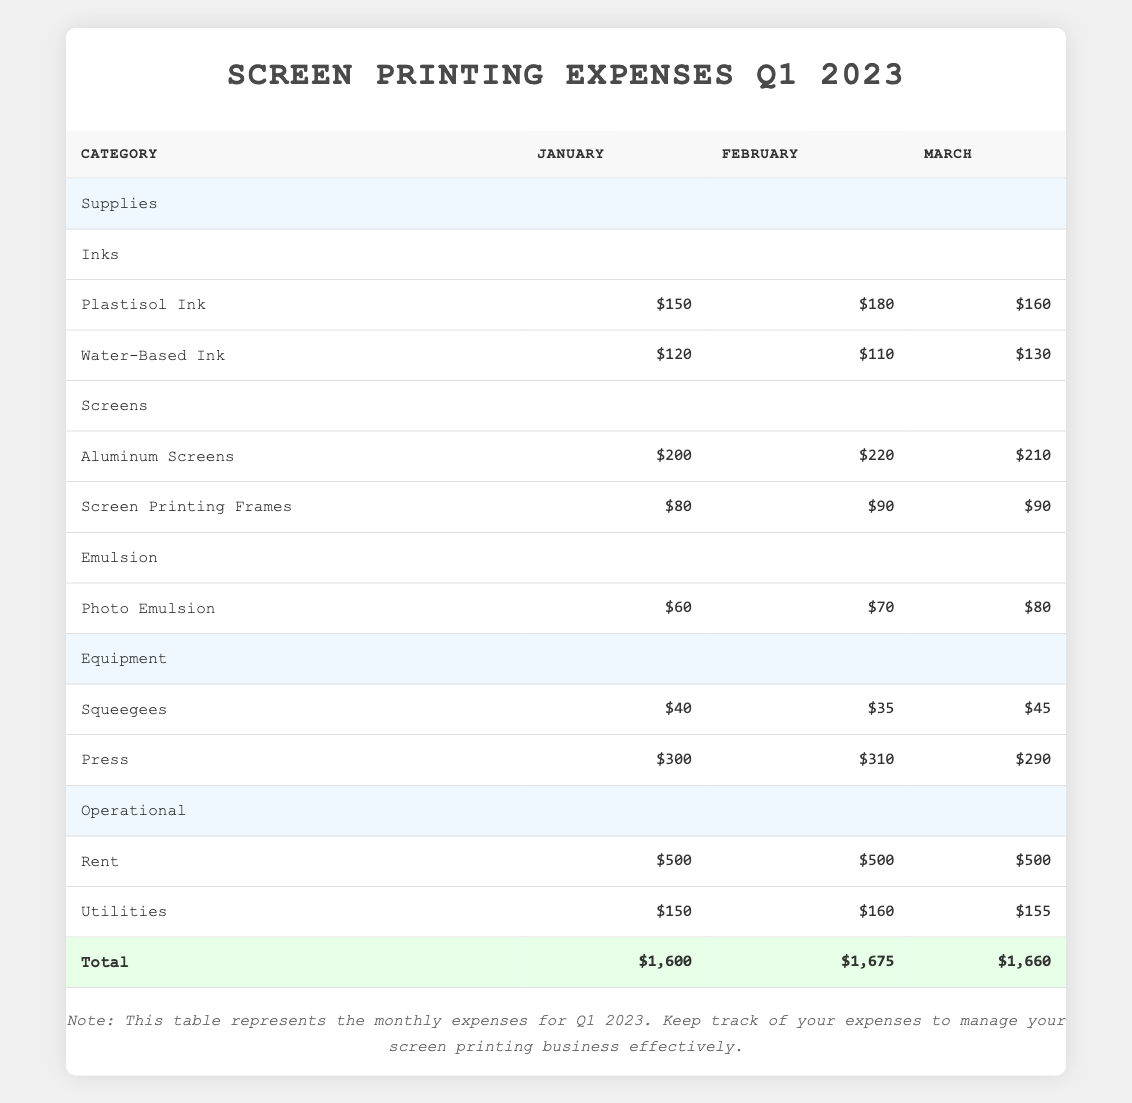what is the total amount spent on supplies in January? In January, the total expense for supplies includes three categories: Inks, Screens, and Emulsion. Adding them up: Inks (150 + 120) = 270, Screens (200 + 80) = 280, Emulsion (60) = 60. Now sum these: 270 + 280 + 60 = 610.
Answer: 610 which month had the highest spending on equipment? In the table, the equipment expenses for each month are: January (40 + 300 = 340), February (35 + 310 = 345), March (45 + 290 = 335). February has the highest total of 345.
Answer: February did the spending on utilities increase from January to February? In January, the utilities expense was 150, and in February, it was 160. Since 160 is greater than 150, the spending did indeed increase.
Answer: Yes what is the average cost of Aluminum Screens over the three months? The expenses for Aluminum Screens are: January (200), February (220), March (210). To find the average, sum these amounts: 200 + 220 + 210 = 630. Then divide by 3 to get the average: 630 / 3 = 210.
Answer: 210 how much more was spent on Rent compared to Utilities in March? In March, the Rent expense was 500, and Utilities expense was 155. To find how much more was spent on Rent, subtract the Utilities amount from Rent: 500 - 155 = 345.
Answer: 345 what was the total spending for the month of February? To get the total spending for February, we must add all expenses: Supplies (Inks 180 + 110 + Screens 220 + 90 + Emulsion 70 = 670), Equipment (35 + 310 = 345), and Operational (Rent 500 + Utilities 160 = 660). Now sum all these totals: 670 + 345 + 660 = 1675.
Answer: 1675 was the total spent on Supplies higher in January or March? In January, the total spent on Supplies was 610. In March, the total was: Inks (160 + 130 = 290), Screens (210 + 90 = 300), Emulsion (80) = 80, so 290 + 300 + 80 = 670. Since 670 is greater than 610, March had higher spending.
Answer: March what is the difference in cost between Water-Based Ink in January and March? The cost for Water-Based Ink in January is 120. In March, it is 130. To find the difference, subtract January's cost from March's: 130 - 120 = 10.
Answer: 10 in which month was the total of operational expenses the same? Operational expenses for Rent are constant at 500 for all three months, but Utilities change: January (150), February (160), March (155). Since Rent is the same, only the total varies. March (500 + 155 = 655), so none of the months have the same total operational expenses.
Answer: None 